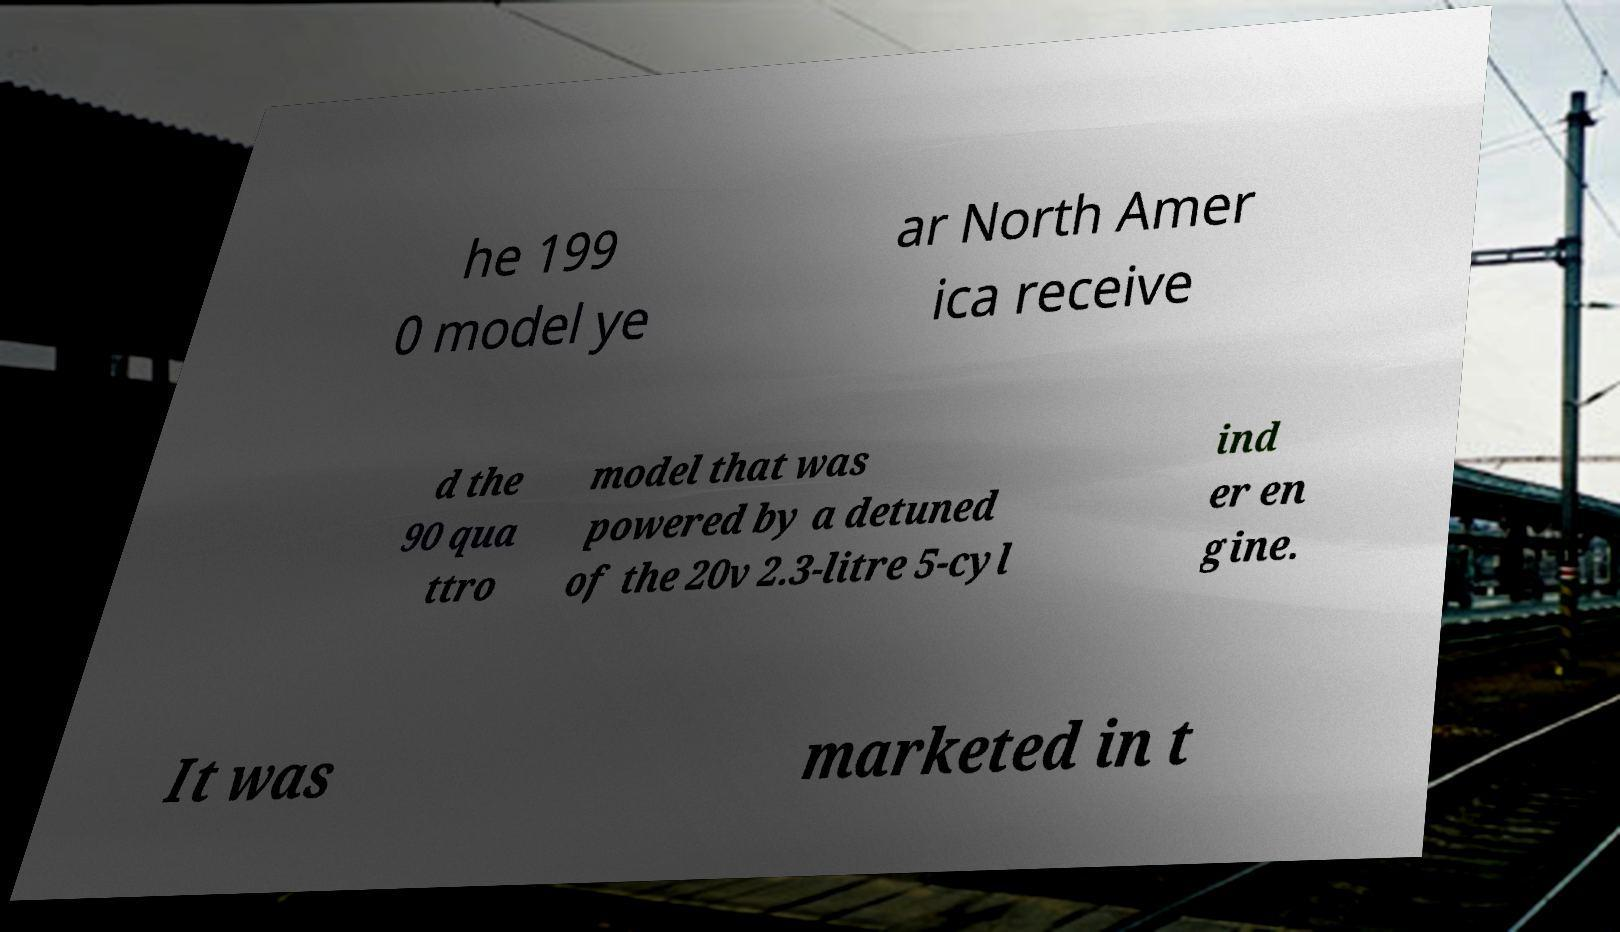Can you read and provide the text displayed in the image?This photo seems to have some interesting text. Can you extract and type it out for me? he 199 0 model ye ar North Amer ica receive d the 90 qua ttro model that was powered by a detuned of the 20v 2.3-litre 5-cyl ind er en gine. It was marketed in t 